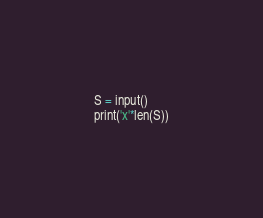Convert code to text. <code><loc_0><loc_0><loc_500><loc_500><_Python_>S = input()
print('x'*len(S))</code> 